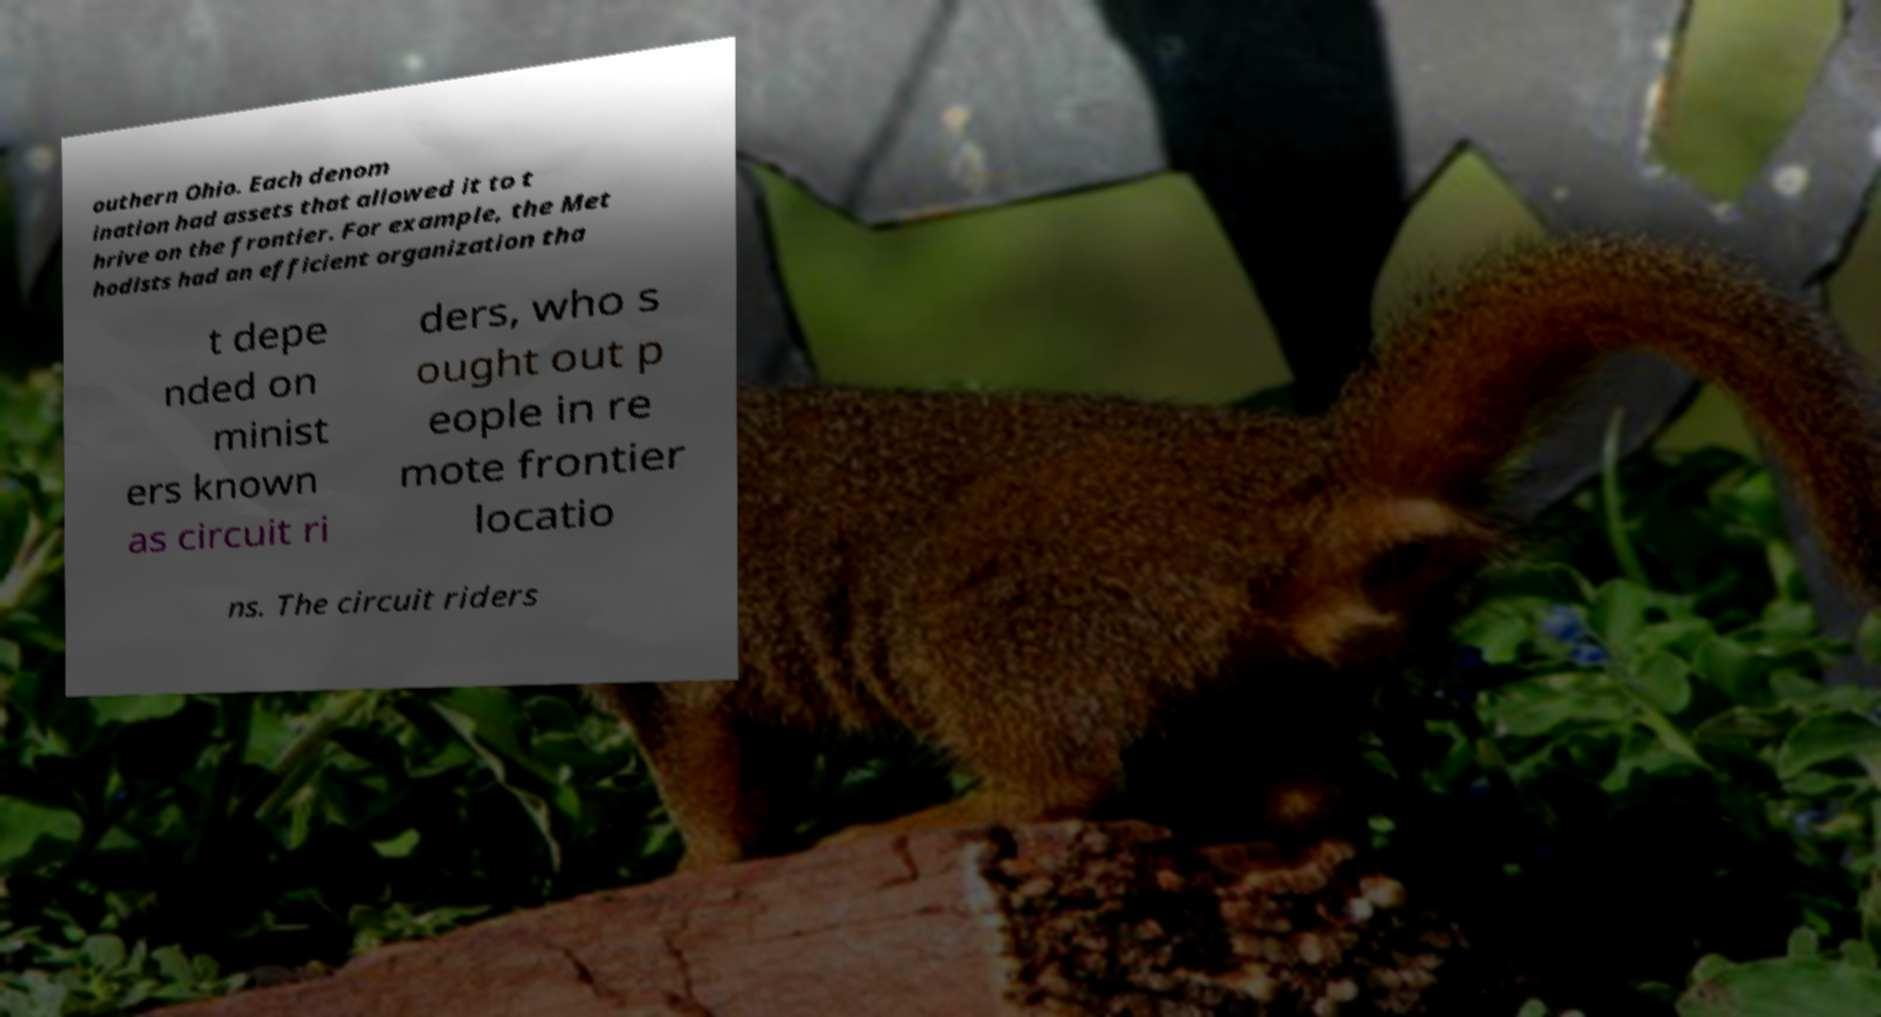There's text embedded in this image that I need extracted. Can you transcribe it verbatim? outhern Ohio. Each denom ination had assets that allowed it to t hrive on the frontier. For example, the Met hodists had an efficient organization tha t depe nded on minist ers known as circuit ri ders, who s ought out p eople in re mote frontier locatio ns. The circuit riders 